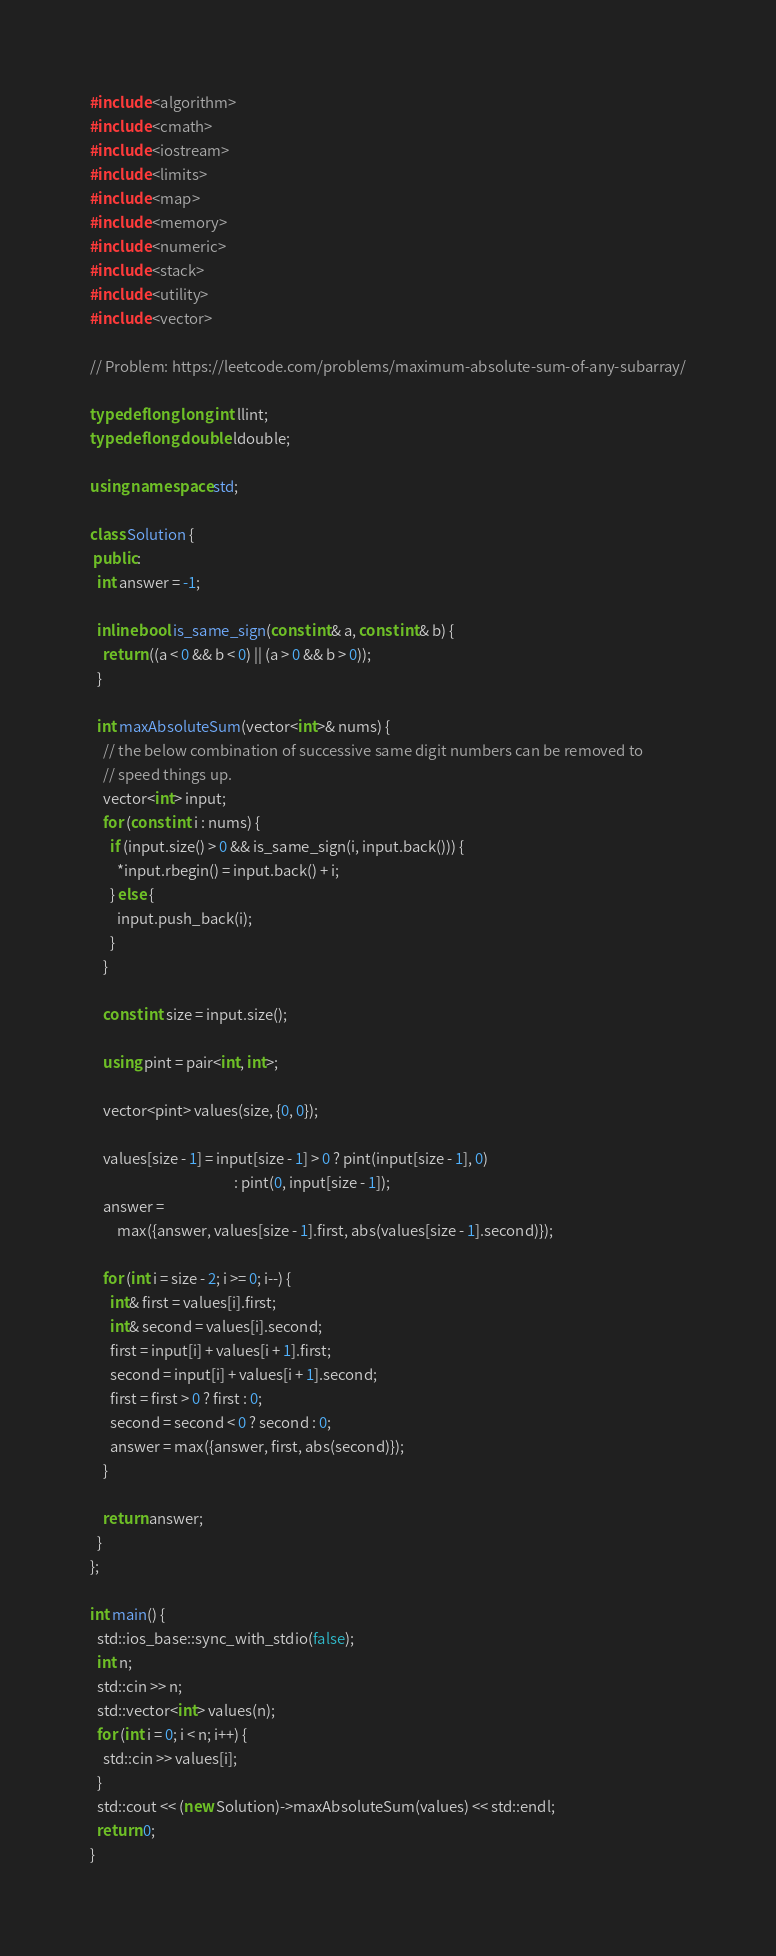<code> <loc_0><loc_0><loc_500><loc_500><_C++_>#include <algorithm>
#include <cmath>
#include <iostream>
#include <limits>
#include <map>
#include <memory>
#include <numeric>
#include <stack>
#include <utility>
#include <vector>

// Problem: https://leetcode.com/problems/maximum-absolute-sum-of-any-subarray/

typedef long long int llint;
typedef long double ldouble;

using namespace std;

class Solution {
 public:
  int answer = -1;

  inline bool is_same_sign(const int& a, const int& b) {
    return ((a < 0 && b < 0) || (a > 0 && b > 0));
  }

  int maxAbsoluteSum(vector<int>& nums) {
    // the below combination of successive same digit numbers can be removed to
    // speed things up.
    vector<int> input;
    for (const int i : nums) {
      if (input.size() > 0 && is_same_sign(i, input.back())) {
        *input.rbegin() = input.back() + i;
      } else {
        input.push_back(i);
      }
    }

    const int size = input.size();

    using pint = pair<int, int>;

    vector<pint> values(size, {0, 0});

    values[size - 1] = input[size - 1] > 0 ? pint(input[size - 1], 0)
                                           : pint(0, input[size - 1]);
    answer =
        max({answer, values[size - 1].first, abs(values[size - 1].second)});

    for (int i = size - 2; i >= 0; i--) {
      int& first = values[i].first;
      int& second = values[i].second;
      first = input[i] + values[i + 1].first;
      second = input[i] + values[i + 1].second;
      first = first > 0 ? first : 0;
      second = second < 0 ? second : 0;
      answer = max({answer, first, abs(second)});
    }

    return answer;
  }
};

int main() {
  std::ios_base::sync_with_stdio(false);
  int n;
  std::cin >> n;
  std::vector<int> values(n);
  for (int i = 0; i < n; i++) {
    std::cin >> values[i];
  }
  std::cout << (new Solution)->maxAbsoluteSum(values) << std::endl;
  return 0;
}
</code> 